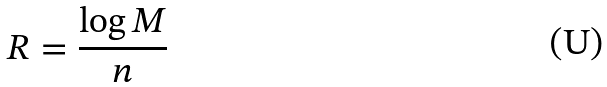Convert formula to latex. <formula><loc_0><loc_0><loc_500><loc_500>R = \frac { \log M } { n }</formula> 